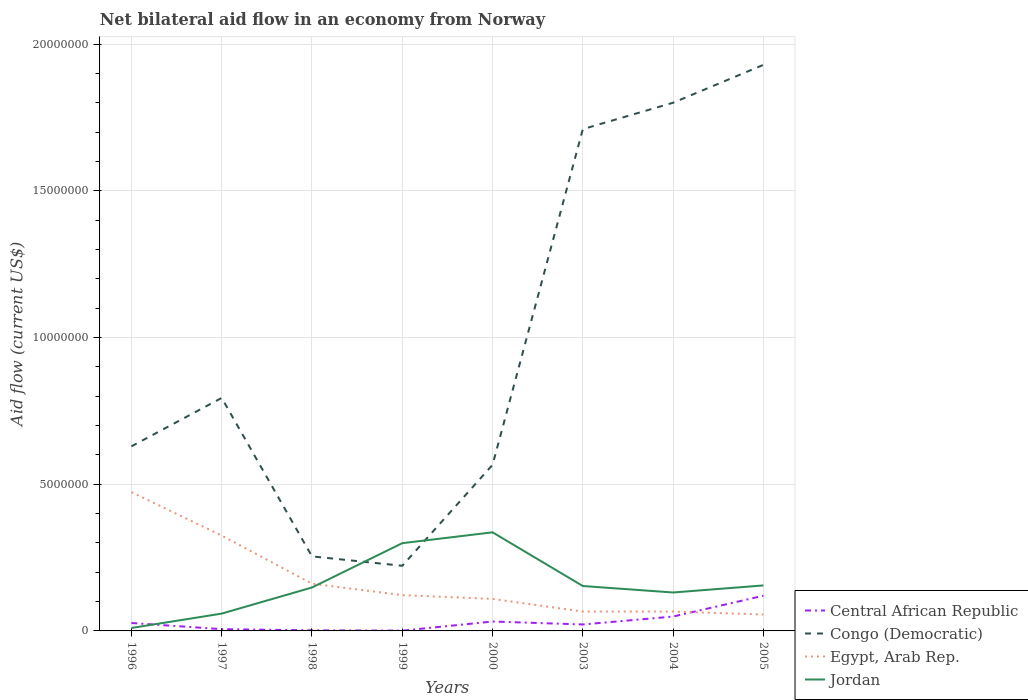What is the total net bilateral aid flow in Congo (Democratic) in the graph?
Keep it short and to the point. -1.68e+07. What is the difference between the highest and the second highest net bilateral aid flow in Egypt, Arab Rep.?
Your response must be concise. 4.17e+06. Is the net bilateral aid flow in Central African Republic strictly greater than the net bilateral aid flow in Jordan over the years?
Your response must be concise. No. How many years are there in the graph?
Offer a very short reply. 8. Does the graph contain any zero values?
Give a very brief answer. No. How many legend labels are there?
Ensure brevity in your answer.  4. What is the title of the graph?
Your response must be concise. Net bilateral aid flow in an economy from Norway. What is the Aid flow (current US$) of Central African Republic in 1996?
Keep it short and to the point. 2.70e+05. What is the Aid flow (current US$) of Congo (Democratic) in 1996?
Make the answer very short. 6.29e+06. What is the Aid flow (current US$) of Egypt, Arab Rep. in 1996?
Offer a very short reply. 4.73e+06. What is the Aid flow (current US$) of Central African Republic in 1997?
Keep it short and to the point. 6.00e+04. What is the Aid flow (current US$) in Congo (Democratic) in 1997?
Your answer should be very brief. 7.94e+06. What is the Aid flow (current US$) of Egypt, Arab Rep. in 1997?
Make the answer very short. 3.25e+06. What is the Aid flow (current US$) of Jordan in 1997?
Offer a terse response. 5.90e+05. What is the Aid flow (current US$) of Congo (Democratic) in 1998?
Make the answer very short. 2.54e+06. What is the Aid flow (current US$) of Egypt, Arab Rep. in 1998?
Ensure brevity in your answer.  1.61e+06. What is the Aid flow (current US$) in Jordan in 1998?
Offer a terse response. 1.48e+06. What is the Aid flow (current US$) of Congo (Democratic) in 1999?
Your answer should be very brief. 2.22e+06. What is the Aid flow (current US$) in Egypt, Arab Rep. in 1999?
Your answer should be very brief. 1.22e+06. What is the Aid flow (current US$) of Jordan in 1999?
Your response must be concise. 2.99e+06. What is the Aid flow (current US$) of Congo (Democratic) in 2000?
Give a very brief answer. 5.66e+06. What is the Aid flow (current US$) of Egypt, Arab Rep. in 2000?
Offer a terse response. 1.09e+06. What is the Aid flow (current US$) of Jordan in 2000?
Provide a short and direct response. 3.36e+06. What is the Aid flow (current US$) of Central African Republic in 2003?
Provide a short and direct response. 2.20e+05. What is the Aid flow (current US$) in Congo (Democratic) in 2003?
Your answer should be very brief. 1.71e+07. What is the Aid flow (current US$) of Jordan in 2003?
Your response must be concise. 1.53e+06. What is the Aid flow (current US$) of Central African Republic in 2004?
Your answer should be very brief. 4.90e+05. What is the Aid flow (current US$) in Congo (Democratic) in 2004?
Your answer should be very brief. 1.80e+07. What is the Aid flow (current US$) of Jordan in 2004?
Make the answer very short. 1.31e+06. What is the Aid flow (current US$) of Central African Republic in 2005?
Your answer should be very brief. 1.20e+06. What is the Aid flow (current US$) of Congo (Democratic) in 2005?
Offer a very short reply. 1.93e+07. What is the Aid flow (current US$) of Egypt, Arab Rep. in 2005?
Give a very brief answer. 5.60e+05. What is the Aid flow (current US$) of Jordan in 2005?
Offer a very short reply. 1.55e+06. Across all years, what is the maximum Aid flow (current US$) in Central African Republic?
Offer a very short reply. 1.20e+06. Across all years, what is the maximum Aid flow (current US$) in Congo (Democratic)?
Your answer should be very brief. 1.93e+07. Across all years, what is the maximum Aid flow (current US$) of Egypt, Arab Rep.?
Ensure brevity in your answer.  4.73e+06. Across all years, what is the maximum Aid flow (current US$) of Jordan?
Offer a very short reply. 3.36e+06. Across all years, what is the minimum Aid flow (current US$) in Central African Republic?
Provide a short and direct response. 10000. Across all years, what is the minimum Aid flow (current US$) of Congo (Democratic)?
Provide a short and direct response. 2.22e+06. Across all years, what is the minimum Aid flow (current US$) in Egypt, Arab Rep.?
Offer a terse response. 5.60e+05. What is the total Aid flow (current US$) of Central African Republic in the graph?
Your answer should be compact. 2.59e+06. What is the total Aid flow (current US$) of Congo (Democratic) in the graph?
Make the answer very short. 7.90e+07. What is the total Aid flow (current US$) of Egypt, Arab Rep. in the graph?
Give a very brief answer. 1.38e+07. What is the total Aid flow (current US$) in Jordan in the graph?
Provide a short and direct response. 1.29e+07. What is the difference between the Aid flow (current US$) of Congo (Democratic) in 1996 and that in 1997?
Offer a very short reply. -1.65e+06. What is the difference between the Aid flow (current US$) in Egypt, Arab Rep. in 1996 and that in 1997?
Offer a very short reply. 1.48e+06. What is the difference between the Aid flow (current US$) in Jordan in 1996 and that in 1997?
Keep it short and to the point. -4.90e+05. What is the difference between the Aid flow (current US$) of Congo (Democratic) in 1996 and that in 1998?
Your response must be concise. 3.75e+06. What is the difference between the Aid flow (current US$) of Egypt, Arab Rep. in 1996 and that in 1998?
Offer a very short reply. 3.12e+06. What is the difference between the Aid flow (current US$) of Jordan in 1996 and that in 1998?
Make the answer very short. -1.38e+06. What is the difference between the Aid flow (current US$) in Congo (Democratic) in 1996 and that in 1999?
Give a very brief answer. 4.07e+06. What is the difference between the Aid flow (current US$) in Egypt, Arab Rep. in 1996 and that in 1999?
Your answer should be very brief. 3.51e+06. What is the difference between the Aid flow (current US$) of Jordan in 1996 and that in 1999?
Your answer should be compact. -2.89e+06. What is the difference between the Aid flow (current US$) of Congo (Democratic) in 1996 and that in 2000?
Give a very brief answer. 6.30e+05. What is the difference between the Aid flow (current US$) of Egypt, Arab Rep. in 1996 and that in 2000?
Make the answer very short. 3.64e+06. What is the difference between the Aid flow (current US$) in Jordan in 1996 and that in 2000?
Provide a succinct answer. -3.26e+06. What is the difference between the Aid flow (current US$) in Congo (Democratic) in 1996 and that in 2003?
Give a very brief answer. -1.08e+07. What is the difference between the Aid flow (current US$) of Egypt, Arab Rep. in 1996 and that in 2003?
Provide a short and direct response. 4.07e+06. What is the difference between the Aid flow (current US$) in Jordan in 1996 and that in 2003?
Ensure brevity in your answer.  -1.43e+06. What is the difference between the Aid flow (current US$) in Congo (Democratic) in 1996 and that in 2004?
Offer a terse response. -1.17e+07. What is the difference between the Aid flow (current US$) of Egypt, Arab Rep. in 1996 and that in 2004?
Your answer should be very brief. 4.07e+06. What is the difference between the Aid flow (current US$) of Jordan in 1996 and that in 2004?
Provide a short and direct response. -1.21e+06. What is the difference between the Aid flow (current US$) of Central African Republic in 1996 and that in 2005?
Offer a terse response. -9.30e+05. What is the difference between the Aid flow (current US$) in Congo (Democratic) in 1996 and that in 2005?
Offer a terse response. -1.30e+07. What is the difference between the Aid flow (current US$) of Egypt, Arab Rep. in 1996 and that in 2005?
Give a very brief answer. 4.17e+06. What is the difference between the Aid flow (current US$) of Jordan in 1996 and that in 2005?
Provide a short and direct response. -1.45e+06. What is the difference between the Aid flow (current US$) of Central African Republic in 1997 and that in 1998?
Ensure brevity in your answer.  4.00e+04. What is the difference between the Aid flow (current US$) in Congo (Democratic) in 1997 and that in 1998?
Provide a succinct answer. 5.40e+06. What is the difference between the Aid flow (current US$) of Egypt, Arab Rep. in 1997 and that in 1998?
Your response must be concise. 1.64e+06. What is the difference between the Aid flow (current US$) in Jordan in 1997 and that in 1998?
Ensure brevity in your answer.  -8.90e+05. What is the difference between the Aid flow (current US$) of Congo (Democratic) in 1997 and that in 1999?
Make the answer very short. 5.72e+06. What is the difference between the Aid flow (current US$) in Egypt, Arab Rep. in 1997 and that in 1999?
Offer a terse response. 2.03e+06. What is the difference between the Aid flow (current US$) in Jordan in 1997 and that in 1999?
Your answer should be compact. -2.40e+06. What is the difference between the Aid flow (current US$) in Congo (Democratic) in 1997 and that in 2000?
Keep it short and to the point. 2.28e+06. What is the difference between the Aid flow (current US$) of Egypt, Arab Rep. in 1997 and that in 2000?
Offer a terse response. 2.16e+06. What is the difference between the Aid flow (current US$) of Jordan in 1997 and that in 2000?
Give a very brief answer. -2.77e+06. What is the difference between the Aid flow (current US$) in Congo (Democratic) in 1997 and that in 2003?
Your response must be concise. -9.16e+06. What is the difference between the Aid flow (current US$) of Egypt, Arab Rep. in 1997 and that in 2003?
Your answer should be very brief. 2.59e+06. What is the difference between the Aid flow (current US$) of Jordan in 1997 and that in 2003?
Ensure brevity in your answer.  -9.40e+05. What is the difference between the Aid flow (current US$) of Central African Republic in 1997 and that in 2004?
Your answer should be compact. -4.30e+05. What is the difference between the Aid flow (current US$) of Congo (Democratic) in 1997 and that in 2004?
Your answer should be very brief. -1.01e+07. What is the difference between the Aid flow (current US$) of Egypt, Arab Rep. in 1997 and that in 2004?
Provide a short and direct response. 2.59e+06. What is the difference between the Aid flow (current US$) of Jordan in 1997 and that in 2004?
Provide a short and direct response. -7.20e+05. What is the difference between the Aid flow (current US$) of Central African Republic in 1997 and that in 2005?
Give a very brief answer. -1.14e+06. What is the difference between the Aid flow (current US$) in Congo (Democratic) in 1997 and that in 2005?
Keep it short and to the point. -1.14e+07. What is the difference between the Aid flow (current US$) of Egypt, Arab Rep. in 1997 and that in 2005?
Offer a very short reply. 2.69e+06. What is the difference between the Aid flow (current US$) of Jordan in 1997 and that in 2005?
Provide a short and direct response. -9.60e+05. What is the difference between the Aid flow (current US$) in Congo (Democratic) in 1998 and that in 1999?
Your answer should be compact. 3.20e+05. What is the difference between the Aid flow (current US$) of Jordan in 1998 and that in 1999?
Ensure brevity in your answer.  -1.51e+06. What is the difference between the Aid flow (current US$) in Central African Republic in 1998 and that in 2000?
Your answer should be compact. -3.00e+05. What is the difference between the Aid flow (current US$) of Congo (Democratic) in 1998 and that in 2000?
Offer a very short reply. -3.12e+06. What is the difference between the Aid flow (current US$) of Egypt, Arab Rep. in 1998 and that in 2000?
Provide a short and direct response. 5.20e+05. What is the difference between the Aid flow (current US$) of Jordan in 1998 and that in 2000?
Give a very brief answer. -1.88e+06. What is the difference between the Aid flow (current US$) of Central African Republic in 1998 and that in 2003?
Ensure brevity in your answer.  -2.00e+05. What is the difference between the Aid flow (current US$) of Congo (Democratic) in 1998 and that in 2003?
Provide a succinct answer. -1.46e+07. What is the difference between the Aid flow (current US$) in Egypt, Arab Rep. in 1998 and that in 2003?
Your response must be concise. 9.50e+05. What is the difference between the Aid flow (current US$) of Central African Republic in 1998 and that in 2004?
Your answer should be very brief. -4.70e+05. What is the difference between the Aid flow (current US$) in Congo (Democratic) in 1998 and that in 2004?
Give a very brief answer. -1.55e+07. What is the difference between the Aid flow (current US$) in Egypt, Arab Rep. in 1998 and that in 2004?
Provide a short and direct response. 9.50e+05. What is the difference between the Aid flow (current US$) in Central African Republic in 1998 and that in 2005?
Give a very brief answer. -1.18e+06. What is the difference between the Aid flow (current US$) of Congo (Democratic) in 1998 and that in 2005?
Give a very brief answer. -1.68e+07. What is the difference between the Aid flow (current US$) of Egypt, Arab Rep. in 1998 and that in 2005?
Keep it short and to the point. 1.05e+06. What is the difference between the Aid flow (current US$) of Central African Republic in 1999 and that in 2000?
Ensure brevity in your answer.  -3.10e+05. What is the difference between the Aid flow (current US$) in Congo (Democratic) in 1999 and that in 2000?
Offer a very short reply. -3.44e+06. What is the difference between the Aid flow (current US$) in Jordan in 1999 and that in 2000?
Provide a succinct answer. -3.70e+05. What is the difference between the Aid flow (current US$) of Central African Republic in 1999 and that in 2003?
Your answer should be compact. -2.10e+05. What is the difference between the Aid flow (current US$) in Congo (Democratic) in 1999 and that in 2003?
Provide a short and direct response. -1.49e+07. What is the difference between the Aid flow (current US$) in Egypt, Arab Rep. in 1999 and that in 2003?
Your response must be concise. 5.60e+05. What is the difference between the Aid flow (current US$) of Jordan in 1999 and that in 2003?
Your response must be concise. 1.46e+06. What is the difference between the Aid flow (current US$) of Central African Republic in 1999 and that in 2004?
Your answer should be very brief. -4.80e+05. What is the difference between the Aid flow (current US$) in Congo (Democratic) in 1999 and that in 2004?
Make the answer very short. -1.58e+07. What is the difference between the Aid flow (current US$) of Egypt, Arab Rep. in 1999 and that in 2004?
Make the answer very short. 5.60e+05. What is the difference between the Aid flow (current US$) in Jordan in 1999 and that in 2004?
Provide a short and direct response. 1.68e+06. What is the difference between the Aid flow (current US$) in Central African Republic in 1999 and that in 2005?
Make the answer very short. -1.19e+06. What is the difference between the Aid flow (current US$) of Congo (Democratic) in 1999 and that in 2005?
Offer a very short reply. -1.71e+07. What is the difference between the Aid flow (current US$) in Jordan in 1999 and that in 2005?
Provide a short and direct response. 1.44e+06. What is the difference between the Aid flow (current US$) of Central African Republic in 2000 and that in 2003?
Provide a succinct answer. 1.00e+05. What is the difference between the Aid flow (current US$) of Congo (Democratic) in 2000 and that in 2003?
Offer a very short reply. -1.14e+07. What is the difference between the Aid flow (current US$) in Egypt, Arab Rep. in 2000 and that in 2003?
Your answer should be very brief. 4.30e+05. What is the difference between the Aid flow (current US$) in Jordan in 2000 and that in 2003?
Offer a very short reply. 1.83e+06. What is the difference between the Aid flow (current US$) in Congo (Democratic) in 2000 and that in 2004?
Provide a succinct answer. -1.23e+07. What is the difference between the Aid flow (current US$) of Jordan in 2000 and that in 2004?
Provide a succinct answer. 2.05e+06. What is the difference between the Aid flow (current US$) in Central African Republic in 2000 and that in 2005?
Your response must be concise. -8.80e+05. What is the difference between the Aid flow (current US$) of Congo (Democratic) in 2000 and that in 2005?
Keep it short and to the point. -1.36e+07. What is the difference between the Aid flow (current US$) of Egypt, Arab Rep. in 2000 and that in 2005?
Provide a succinct answer. 5.30e+05. What is the difference between the Aid flow (current US$) in Jordan in 2000 and that in 2005?
Offer a very short reply. 1.81e+06. What is the difference between the Aid flow (current US$) in Central African Republic in 2003 and that in 2004?
Give a very brief answer. -2.70e+05. What is the difference between the Aid flow (current US$) in Congo (Democratic) in 2003 and that in 2004?
Provide a succinct answer. -9.00e+05. What is the difference between the Aid flow (current US$) of Egypt, Arab Rep. in 2003 and that in 2004?
Offer a terse response. 0. What is the difference between the Aid flow (current US$) of Central African Republic in 2003 and that in 2005?
Your answer should be very brief. -9.80e+05. What is the difference between the Aid flow (current US$) in Congo (Democratic) in 2003 and that in 2005?
Your response must be concise. -2.19e+06. What is the difference between the Aid flow (current US$) of Central African Republic in 2004 and that in 2005?
Provide a succinct answer. -7.10e+05. What is the difference between the Aid flow (current US$) in Congo (Democratic) in 2004 and that in 2005?
Keep it short and to the point. -1.29e+06. What is the difference between the Aid flow (current US$) in Egypt, Arab Rep. in 2004 and that in 2005?
Your answer should be compact. 1.00e+05. What is the difference between the Aid flow (current US$) of Central African Republic in 1996 and the Aid flow (current US$) of Congo (Democratic) in 1997?
Keep it short and to the point. -7.67e+06. What is the difference between the Aid flow (current US$) in Central African Republic in 1996 and the Aid flow (current US$) in Egypt, Arab Rep. in 1997?
Keep it short and to the point. -2.98e+06. What is the difference between the Aid flow (current US$) in Central African Republic in 1996 and the Aid flow (current US$) in Jordan in 1997?
Offer a terse response. -3.20e+05. What is the difference between the Aid flow (current US$) of Congo (Democratic) in 1996 and the Aid flow (current US$) of Egypt, Arab Rep. in 1997?
Make the answer very short. 3.04e+06. What is the difference between the Aid flow (current US$) of Congo (Democratic) in 1996 and the Aid flow (current US$) of Jordan in 1997?
Offer a very short reply. 5.70e+06. What is the difference between the Aid flow (current US$) of Egypt, Arab Rep. in 1996 and the Aid flow (current US$) of Jordan in 1997?
Your answer should be very brief. 4.14e+06. What is the difference between the Aid flow (current US$) of Central African Republic in 1996 and the Aid flow (current US$) of Congo (Democratic) in 1998?
Provide a short and direct response. -2.27e+06. What is the difference between the Aid flow (current US$) in Central African Republic in 1996 and the Aid flow (current US$) in Egypt, Arab Rep. in 1998?
Provide a succinct answer. -1.34e+06. What is the difference between the Aid flow (current US$) of Central African Republic in 1996 and the Aid flow (current US$) of Jordan in 1998?
Ensure brevity in your answer.  -1.21e+06. What is the difference between the Aid flow (current US$) in Congo (Democratic) in 1996 and the Aid flow (current US$) in Egypt, Arab Rep. in 1998?
Ensure brevity in your answer.  4.68e+06. What is the difference between the Aid flow (current US$) in Congo (Democratic) in 1996 and the Aid flow (current US$) in Jordan in 1998?
Make the answer very short. 4.81e+06. What is the difference between the Aid flow (current US$) of Egypt, Arab Rep. in 1996 and the Aid flow (current US$) of Jordan in 1998?
Keep it short and to the point. 3.25e+06. What is the difference between the Aid flow (current US$) of Central African Republic in 1996 and the Aid flow (current US$) of Congo (Democratic) in 1999?
Provide a succinct answer. -1.95e+06. What is the difference between the Aid flow (current US$) in Central African Republic in 1996 and the Aid flow (current US$) in Egypt, Arab Rep. in 1999?
Your response must be concise. -9.50e+05. What is the difference between the Aid flow (current US$) in Central African Republic in 1996 and the Aid flow (current US$) in Jordan in 1999?
Your response must be concise. -2.72e+06. What is the difference between the Aid flow (current US$) of Congo (Democratic) in 1996 and the Aid flow (current US$) of Egypt, Arab Rep. in 1999?
Give a very brief answer. 5.07e+06. What is the difference between the Aid flow (current US$) of Congo (Democratic) in 1996 and the Aid flow (current US$) of Jordan in 1999?
Ensure brevity in your answer.  3.30e+06. What is the difference between the Aid flow (current US$) in Egypt, Arab Rep. in 1996 and the Aid flow (current US$) in Jordan in 1999?
Provide a succinct answer. 1.74e+06. What is the difference between the Aid flow (current US$) of Central African Republic in 1996 and the Aid flow (current US$) of Congo (Democratic) in 2000?
Give a very brief answer. -5.39e+06. What is the difference between the Aid flow (current US$) in Central African Republic in 1996 and the Aid flow (current US$) in Egypt, Arab Rep. in 2000?
Give a very brief answer. -8.20e+05. What is the difference between the Aid flow (current US$) in Central African Republic in 1996 and the Aid flow (current US$) in Jordan in 2000?
Ensure brevity in your answer.  -3.09e+06. What is the difference between the Aid flow (current US$) in Congo (Democratic) in 1996 and the Aid flow (current US$) in Egypt, Arab Rep. in 2000?
Give a very brief answer. 5.20e+06. What is the difference between the Aid flow (current US$) in Congo (Democratic) in 1996 and the Aid flow (current US$) in Jordan in 2000?
Keep it short and to the point. 2.93e+06. What is the difference between the Aid flow (current US$) in Egypt, Arab Rep. in 1996 and the Aid flow (current US$) in Jordan in 2000?
Give a very brief answer. 1.37e+06. What is the difference between the Aid flow (current US$) of Central African Republic in 1996 and the Aid flow (current US$) of Congo (Democratic) in 2003?
Your response must be concise. -1.68e+07. What is the difference between the Aid flow (current US$) of Central African Republic in 1996 and the Aid flow (current US$) of Egypt, Arab Rep. in 2003?
Give a very brief answer. -3.90e+05. What is the difference between the Aid flow (current US$) of Central African Republic in 1996 and the Aid flow (current US$) of Jordan in 2003?
Your response must be concise. -1.26e+06. What is the difference between the Aid flow (current US$) in Congo (Democratic) in 1996 and the Aid flow (current US$) in Egypt, Arab Rep. in 2003?
Provide a short and direct response. 5.63e+06. What is the difference between the Aid flow (current US$) in Congo (Democratic) in 1996 and the Aid flow (current US$) in Jordan in 2003?
Ensure brevity in your answer.  4.76e+06. What is the difference between the Aid flow (current US$) in Egypt, Arab Rep. in 1996 and the Aid flow (current US$) in Jordan in 2003?
Your response must be concise. 3.20e+06. What is the difference between the Aid flow (current US$) of Central African Republic in 1996 and the Aid flow (current US$) of Congo (Democratic) in 2004?
Give a very brief answer. -1.77e+07. What is the difference between the Aid flow (current US$) of Central African Republic in 1996 and the Aid flow (current US$) of Egypt, Arab Rep. in 2004?
Provide a short and direct response. -3.90e+05. What is the difference between the Aid flow (current US$) in Central African Republic in 1996 and the Aid flow (current US$) in Jordan in 2004?
Make the answer very short. -1.04e+06. What is the difference between the Aid flow (current US$) of Congo (Democratic) in 1996 and the Aid flow (current US$) of Egypt, Arab Rep. in 2004?
Your answer should be compact. 5.63e+06. What is the difference between the Aid flow (current US$) of Congo (Democratic) in 1996 and the Aid flow (current US$) of Jordan in 2004?
Make the answer very short. 4.98e+06. What is the difference between the Aid flow (current US$) in Egypt, Arab Rep. in 1996 and the Aid flow (current US$) in Jordan in 2004?
Give a very brief answer. 3.42e+06. What is the difference between the Aid flow (current US$) in Central African Republic in 1996 and the Aid flow (current US$) in Congo (Democratic) in 2005?
Give a very brief answer. -1.90e+07. What is the difference between the Aid flow (current US$) of Central African Republic in 1996 and the Aid flow (current US$) of Egypt, Arab Rep. in 2005?
Make the answer very short. -2.90e+05. What is the difference between the Aid flow (current US$) of Central African Republic in 1996 and the Aid flow (current US$) of Jordan in 2005?
Your answer should be very brief. -1.28e+06. What is the difference between the Aid flow (current US$) in Congo (Democratic) in 1996 and the Aid flow (current US$) in Egypt, Arab Rep. in 2005?
Offer a terse response. 5.73e+06. What is the difference between the Aid flow (current US$) in Congo (Democratic) in 1996 and the Aid flow (current US$) in Jordan in 2005?
Your response must be concise. 4.74e+06. What is the difference between the Aid flow (current US$) of Egypt, Arab Rep. in 1996 and the Aid flow (current US$) of Jordan in 2005?
Make the answer very short. 3.18e+06. What is the difference between the Aid flow (current US$) of Central African Republic in 1997 and the Aid flow (current US$) of Congo (Democratic) in 1998?
Make the answer very short. -2.48e+06. What is the difference between the Aid flow (current US$) of Central African Republic in 1997 and the Aid flow (current US$) of Egypt, Arab Rep. in 1998?
Make the answer very short. -1.55e+06. What is the difference between the Aid flow (current US$) of Central African Republic in 1997 and the Aid flow (current US$) of Jordan in 1998?
Your answer should be compact. -1.42e+06. What is the difference between the Aid flow (current US$) in Congo (Democratic) in 1997 and the Aid flow (current US$) in Egypt, Arab Rep. in 1998?
Keep it short and to the point. 6.33e+06. What is the difference between the Aid flow (current US$) in Congo (Democratic) in 1997 and the Aid flow (current US$) in Jordan in 1998?
Your response must be concise. 6.46e+06. What is the difference between the Aid flow (current US$) of Egypt, Arab Rep. in 1997 and the Aid flow (current US$) of Jordan in 1998?
Your answer should be compact. 1.77e+06. What is the difference between the Aid flow (current US$) of Central African Republic in 1997 and the Aid flow (current US$) of Congo (Democratic) in 1999?
Your answer should be very brief. -2.16e+06. What is the difference between the Aid flow (current US$) in Central African Republic in 1997 and the Aid flow (current US$) in Egypt, Arab Rep. in 1999?
Your answer should be very brief. -1.16e+06. What is the difference between the Aid flow (current US$) of Central African Republic in 1997 and the Aid flow (current US$) of Jordan in 1999?
Offer a very short reply. -2.93e+06. What is the difference between the Aid flow (current US$) in Congo (Democratic) in 1997 and the Aid flow (current US$) in Egypt, Arab Rep. in 1999?
Give a very brief answer. 6.72e+06. What is the difference between the Aid flow (current US$) in Congo (Democratic) in 1997 and the Aid flow (current US$) in Jordan in 1999?
Provide a succinct answer. 4.95e+06. What is the difference between the Aid flow (current US$) in Central African Republic in 1997 and the Aid flow (current US$) in Congo (Democratic) in 2000?
Your answer should be very brief. -5.60e+06. What is the difference between the Aid flow (current US$) of Central African Republic in 1997 and the Aid flow (current US$) of Egypt, Arab Rep. in 2000?
Provide a short and direct response. -1.03e+06. What is the difference between the Aid flow (current US$) of Central African Republic in 1997 and the Aid flow (current US$) of Jordan in 2000?
Offer a very short reply. -3.30e+06. What is the difference between the Aid flow (current US$) in Congo (Democratic) in 1997 and the Aid flow (current US$) in Egypt, Arab Rep. in 2000?
Provide a succinct answer. 6.85e+06. What is the difference between the Aid flow (current US$) of Congo (Democratic) in 1997 and the Aid flow (current US$) of Jordan in 2000?
Provide a short and direct response. 4.58e+06. What is the difference between the Aid flow (current US$) in Central African Republic in 1997 and the Aid flow (current US$) in Congo (Democratic) in 2003?
Make the answer very short. -1.70e+07. What is the difference between the Aid flow (current US$) in Central African Republic in 1997 and the Aid flow (current US$) in Egypt, Arab Rep. in 2003?
Keep it short and to the point. -6.00e+05. What is the difference between the Aid flow (current US$) of Central African Republic in 1997 and the Aid flow (current US$) of Jordan in 2003?
Provide a succinct answer. -1.47e+06. What is the difference between the Aid flow (current US$) of Congo (Democratic) in 1997 and the Aid flow (current US$) of Egypt, Arab Rep. in 2003?
Make the answer very short. 7.28e+06. What is the difference between the Aid flow (current US$) of Congo (Democratic) in 1997 and the Aid flow (current US$) of Jordan in 2003?
Your answer should be very brief. 6.41e+06. What is the difference between the Aid flow (current US$) in Egypt, Arab Rep. in 1997 and the Aid flow (current US$) in Jordan in 2003?
Your answer should be very brief. 1.72e+06. What is the difference between the Aid flow (current US$) of Central African Republic in 1997 and the Aid flow (current US$) of Congo (Democratic) in 2004?
Provide a short and direct response. -1.79e+07. What is the difference between the Aid flow (current US$) in Central African Republic in 1997 and the Aid flow (current US$) in Egypt, Arab Rep. in 2004?
Your answer should be very brief. -6.00e+05. What is the difference between the Aid flow (current US$) in Central African Republic in 1997 and the Aid flow (current US$) in Jordan in 2004?
Make the answer very short. -1.25e+06. What is the difference between the Aid flow (current US$) of Congo (Democratic) in 1997 and the Aid flow (current US$) of Egypt, Arab Rep. in 2004?
Your response must be concise. 7.28e+06. What is the difference between the Aid flow (current US$) in Congo (Democratic) in 1997 and the Aid flow (current US$) in Jordan in 2004?
Your answer should be very brief. 6.63e+06. What is the difference between the Aid flow (current US$) of Egypt, Arab Rep. in 1997 and the Aid flow (current US$) of Jordan in 2004?
Make the answer very short. 1.94e+06. What is the difference between the Aid flow (current US$) in Central African Republic in 1997 and the Aid flow (current US$) in Congo (Democratic) in 2005?
Keep it short and to the point. -1.92e+07. What is the difference between the Aid flow (current US$) of Central African Republic in 1997 and the Aid flow (current US$) of Egypt, Arab Rep. in 2005?
Provide a short and direct response. -5.00e+05. What is the difference between the Aid flow (current US$) in Central African Republic in 1997 and the Aid flow (current US$) in Jordan in 2005?
Keep it short and to the point. -1.49e+06. What is the difference between the Aid flow (current US$) of Congo (Democratic) in 1997 and the Aid flow (current US$) of Egypt, Arab Rep. in 2005?
Offer a very short reply. 7.38e+06. What is the difference between the Aid flow (current US$) in Congo (Democratic) in 1997 and the Aid flow (current US$) in Jordan in 2005?
Give a very brief answer. 6.39e+06. What is the difference between the Aid flow (current US$) of Egypt, Arab Rep. in 1997 and the Aid flow (current US$) of Jordan in 2005?
Make the answer very short. 1.70e+06. What is the difference between the Aid flow (current US$) in Central African Republic in 1998 and the Aid flow (current US$) in Congo (Democratic) in 1999?
Provide a short and direct response. -2.20e+06. What is the difference between the Aid flow (current US$) of Central African Republic in 1998 and the Aid flow (current US$) of Egypt, Arab Rep. in 1999?
Keep it short and to the point. -1.20e+06. What is the difference between the Aid flow (current US$) of Central African Republic in 1998 and the Aid flow (current US$) of Jordan in 1999?
Your answer should be very brief. -2.97e+06. What is the difference between the Aid flow (current US$) in Congo (Democratic) in 1998 and the Aid flow (current US$) in Egypt, Arab Rep. in 1999?
Ensure brevity in your answer.  1.32e+06. What is the difference between the Aid flow (current US$) in Congo (Democratic) in 1998 and the Aid flow (current US$) in Jordan in 1999?
Offer a terse response. -4.50e+05. What is the difference between the Aid flow (current US$) of Egypt, Arab Rep. in 1998 and the Aid flow (current US$) of Jordan in 1999?
Ensure brevity in your answer.  -1.38e+06. What is the difference between the Aid flow (current US$) in Central African Republic in 1998 and the Aid flow (current US$) in Congo (Democratic) in 2000?
Offer a terse response. -5.64e+06. What is the difference between the Aid flow (current US$) of Central African Republic in 1998 and the Aid flow (current US$) of Egypt, Arab Rep. in 2000?
Your answer should be very brief. -1.07e+06. What is the difference between the Aid flow (current US$) in Central African Republic in 1998 and the Aid flow (current US$) in Jordan in 2000?
Give a very brief answer. -3.34e+06. What is the difference between the Aid flow (current US$) in Congo (Democratic) in 1998 and the Aid flow (current US$) in Egypt, Arab Rep. in 2000?
Provide a short and direct response. 1.45e+06. What is the difference between the Aid flow (current US$) in Congo (Democratic) in 1998 and the Aid flow (current US$) in Jordan in 2000?
Your answer should be very brief. -8.20e+05. What is the difference between the Aid flow (current US$) of Egypt, Arab Rep. in 1998 and the Aid flow (current US$) of Jordan in 2000?
Offer a terse response. -1.75e+06. What is the difference between the Aid flow (current US$) in Central African Republic in 1998 and the Aid flow (current US$) in Congo (Democratic) in 2003?
Keep it short and to the point. -1.71e+07. What is the difference between the Aid flow (current US$) of Central African Republic in 1998 and the Aid flow (current US$) of Egypt, Arab Rep. in 2003?
Your answer should be very brief. -6.40e+05. What is the difference between the Aid flow (current US$) in Central African Republic in 1998 and the Aid flow (current US$) in Jordan in 2003?
Provide a short and direct response. -1.51e+06. What is the difference between the Aid flow (current US$) in Congo (Democratic) in 1998 and the Aid flow (current US$) in Egypt, Arab Rep. in 2003?
Your response must be concise. 1.88e+06. What is the difference between the Aid flow (current US$) of Congo (Democratic) in 1998 and the Aid flow (current US$) of Jordan in 2003?
Keep it short and to the point. 1.01e+06. What is the difference between the Aid flow (current US$) of Egypt, Arab Rep. in 1998 and the Aid flow (current US$) of Jordan in 2003?
Offer a very short reply. 8.00e+04. What is the difference between the Aid flow (current US$) in Central African Republic in 1998 and the Aid flow (current US$) in Congo (Democratic) in 2004?
Your response must be concise. -1.80e+07. What is the difference between the Aid flow (current US$) in Central African Republic in 1998 and the Aid flow (current US$) in Egypt, Arab Rep. in 2004?
Your answer should be very brief. -6.40e+05. What is the difference between the Aid flow (current US$) in Central African Republic in 1998 and the Aid flow (current US$) in Jordan in 2004?
Provide a succinct answer. -1.29e+06. What is the difference between the Aid flow (current US$) of Congo (Democratic) in 1998 and the Aid flow (current US$) of Egypt, Arab Rep. in 2004?
Provide a succinct answer. 1.88e+06. What is the difference between the Aid flow (current US$) in Congo (Democratic) in 1998 and the Aid flow (current US$) in Jordan in 2004?
Provide a succinct answer. 1.23e+06. What is the difference between the Aid flow (current US$) of Central African Republic in 1998 and the Aid flow (current US$) of Congo (Democratic) in 2005?
Provide a succinct answer. -1.93e+07. What is the difference between the Aid flow (current US$) in Central African Republic in 1998 and the Aid flow (current US$) in Egypt, Arab Rep. in 2005?
Offer a terse response. -5.40e+05. What is the difference between the Aid flow (current US$) in Central African Republic in 1998 and the Aid flow (current US$) in Jordan in 2005?
Provide a succinct answer. -1.53e+06. What is the difference between the Aid flow (current US$) of Congo (Democratic) in 1998 and the Aid flow (current US$) of Egypt, Arab Rep. in 2005?
Your answer should be compact. 1.98e+06. What is the difference between the Aid flow (current US$) in Congo (Democratic) in 1998 and the Aid flow (current US$) in Jordan in 2005?
Offer a terse response. 9.90e+05. What is the difference between the Aid flow (current US$) of Central African Republic in 1999 and the Aid flow (current US$) of Congo (Democratic) in 2000?
Provide a short and direct response. -5.65e+06. What is the difference between the Aid flow (current US$) of Central African Republic in 1999 and the Aid flow (current US$) of Egypt, Arab Rep. in 2000?
Provide a succinct answer. -1.08e+06. What is the difference between the Aid flow (current US$) of Central African Republic in 1999 and the Aid flow (current US$) of Jordan in 2000?
Provide a succinct answer. -3.35e+06. What is the difference between the Aid flow (current US$) of Congo (Democratic) in 1999 and the Aid flow (current US$) of Egypt, Arab Rep. in 2000?
Provide a short and direct response. 1.13e+06. What is the difference between the Aid flow (current US$) in Congo (Democratic) in 1999 and the Aid flow (current US$) in Jordan in 2000?
Provide a short and direct response. -1.14e+06. What is the difference between the Aid flow (current US$) in Egypt, Arab Rep. in 1999 and the Aid flow (current US$) in Jordan in 2000?
Ensure brevity in your answer.  -2.14e+06. What is the difference between the Aid flow (current US$) of Central African Republic in 1999 and the Aid flow (current US$) of Congo (Democratic) in 2003?
Your response must be concise. -1.71e+07. What is the difference between the Aid flow (current US$) of Central African Republic in 1999 and the Aid flow (current US$) of Egypt, Arab Rep. in 2003?
Provide a short and direct response. -6.50e+05. What is the difference between the Aid flow (current US$) of Central African Republic in 1999 and the Aid flow (current US$) of Jordan in 2003?
Offer a terse response. -1.52e+06. What is the difference between the Aid flow (current US$) of Congo (Democratic) in 1999 and the Aid flow (current US$) of Egypt, Arab Rep. in 2003?
Make the answer very short. 1.56e+06. What is the difference between the Aid flow (current US$) in Congo (Democratic) in 1999 and the Aid flow (current US$) in Jordan in 2003?
Ensure brevity in your answer.  6.90e+05. What is the difference between the Aid flow (current US$) in Egypt, Arab Rep. in 1999 and the Aid flow (current US$) in Jordan in 2003?
Provide a short and direct response. -3.10e+05. What is the difference between the Aid flow (current US$) of Central African Republic in 1999 and the Aid flow (current US$) of Congo (Democratic) in 2004?
Your answer should be compact. -1.80e+07. What is the difference between the Aid flow (current US$) in Central African Republic in 1999 and the Aid flow (current US$) in Egypt, Arab Rep. in 2004?
Your answer should be compact. -6.50e+05. What is the difference between the Aid flow (current US$) in Central African Republic in 1999 and the Aid flow (current US$) in Jordan in 2004?
Your answer should be very brief. -1.30e+06. What is the difference between the Aid flow (current US$) in Congo (Democratic) in 1999 and the Aid flow (current US$) in Egypt, Arab Rep. in 2004?
Keep it short and to the point. 1.56e+06. What is the difference between the Aid flow (current US$) of Congo (Democratic) in 1999 and the Aid flow (current US$) of Jordan in 2004?
Make the answer very short. 9.10e+05. What is the difference between the Aid flow (current US$) in Central African Republic in 1999 and the Aid flow (current US$) in Congo (Democratic) in 2005?
Ensure brevity in your answer.  -1.93e+07. What is the difference between the Aid flow (current US$) in Central African Republic in 1999 and the Aid flow (current US$) in Egypt, Arab Rep. in 2005?
Give a very brief answer. -5.50e+05. What is the difference between the Aid flow (current US$) of Central African Republic in 1999 and the Aid flow (current US$) of Jordan in 2005?
Your answer should be compact. -1.54e+06. What is the difference between the Aid flow (current US$) in Congo (Democratic) in 1999 and the Aid flow (current US$) in Egypt, Arab Rep. in 2005?
Your response must be concise. 1.66e+06. What is the difference between the Aid flow (current US$) of Congo (Democratic) in 1999 and the Aid flow (current US$) of Jordan in 2005?
Your answer should be very brief. 6.70e+05. What is the difference between the Aid flow (current US$) in Egypt, Arab Rep. in 1999 and the Aid flow (current US$) in Jordan in 2005?
Give a very brief answer. -3.30e+05. What is the difference between the Aid flow (current US$) of Central African Republic in 2000 and the Aid flow (current US$) of Congo (Democratic) in 2003?
Your answer should be very brief. -1.68e+07. What is the difference between the Aid flow (current US$) in Central African Republic in 2000 and the Aid flow (current US$) in Jordan in 2003?
Ensure brevity in your answer.  -1.21e+06. What is the difference between the Aid flow (current US$) of Congo (Democratic) in 2000 and the Aid flow (current US$) of Egypt, Arab Rep. in 2003?
Keep it short and to the point. 5.00e+06. What is the difference between the Aid flow (current US$) of Congo (Democratic) in 2000 and the Aid flow (current US$) of Jordan in 2003?
Keep it short and to the point. 4.13e+06. What is the difference between the Aid flow (current US$) in Egypt, Arab Rep. in 2000 and the Aid flow (current US$) in Jordan in 2003?
Give a very brief answer. -4.40e+05. What is the difference between the Aid flow (current US$) in Central African Republic in 2000 and the Aid flow (current US$) in Congo (Democratic) in 2004?
Offer a terse response. -1.77e+07. What is the difference between the Aid flow (current US$) in Central African Republic in 2000 and the Aid flow (current US$) in Egypt, Arab Rep. in 2004?
Offer a terse response. -3.40e+05. What is the difference between the Aid flow (current US$) in Central African Republic in 2000 and the Aid flow (current US$) in Jordan in 2004?
Make the answer very short. -9.90e+05. What is the difference between the Aid flow (current US$) of Congo (Democratic) in 2000 and the Aid flow (current US$) of Egypt, Arab Rep. in 2004?
Offer a terse response. 5.00e+06. What is the difference between the Aid flow (current US$) in Congo (Democratic) in 2000 and the Aid flow (current US$) in Jordan in 2004?
Your response must be concise. 4.35e+06. What is the difference between the Aid flow (current US$) of Egypt, Arab Rep. in 2000 and the Aid flow (current US$) of Jordan in 2004?
Ensure brevity in your answer.  -2.20e+05. What is the difference between the Aid flow (current US$) in Central African Republic in 2000 and the Aid flow (current US$) in Congo (Democratic) in 2005?
Offer a very short reply. -1.90e+07. What is the difference between the Aid flow (current US$) in Central African Republic in 2000 and the Aid flow (current US$) in Jordan in 2005?
Your response must be concise. -1.23e+06. What is the difference between the Aid flow (current US$) of Congo (Democratic) in 2000 and the Aid flow (current US$) of Egypt, Arab Rep. in 2005?
Your response must be concise. 5.10e+06. What is the difference between the Aid flow (current US$) in Congo (Democratic) in 2000 and the Aid flow (current US$) in Jordan in 2005?
Ensure brevity in your answer.  4.11e+06. What is the difference between the Aid flow (current US$) in Egypt, Arab Rep. in 2000 and the Aid flow (current US$) in Jordan in 2005?
Your response must be concise. -4.60e+05. What is the difference between the Aid flow (current US$) in Central African Republic in 2003 and the Aid flow (current US$) in Congo (Democratic) in 2004?
Give a very brief answer. -1.78e+07. What is the difference between the Aid flow (current US$) in Central African Republic in 2003 and the Aid flow (current US$) in Egypt, Arab Rep. in 2004?
Offer a terse response. -4.40e+05. What is the difference between the Aid flow (current US$) in Central African Republic in 2003 and the Aid flow (current US$) in Jordan in 2004?
Ensure brevity in your answer.  -1.09e+06. What is the difference between the Aid flow (current US$) of Congo (Democratic) in 2003 and the Aid flow (current US$) of Egypt, Arab Rep. in 2004?
Provide a succinct answer. 1.64e+07. What is the difference between the Aid flow (current US$) of Congo (Democratic) in 2003 and the Aid flow (current US$) of Jordan in 2004?
Ensure brevity in your answer.  1.58e+07. What is the difference between the Aid flow (current US$) of Egypt, Arab Rep. in 2003 and the Aid flow (current US$) of Jordan in 2004?
Your answer should be very brief. -6.50e+05. What is the difference between the Aid flow (current US$) of Central African Republic in 2003 and the Aid flow (current US$) of Congo (Democratic) in 2005?
Ensure brevity in your answer.  -1.91e+07. What is the difference between the Aid flow (current US$) of Central African Republic in 2003 and the Aid flow (current US$) of Egypt, Arab Rep. in 2005?
Provide a short and direct response. -3.40e+05. What is the difference between the Aid flow (current US$) of Central African Republic in 2003 and the Aid flow (current US$) of Jordan in 2005?
Offer a very short reply. -1.33e+06. What is the difference between the Aid flow (current US$) in Congo (Democratic) in 2003 and the Aid flow (current US$) in Egypt, Arab Rep. in 2005?
Make the answer very short. 1.65e+07. What is the difference between the Aid flow (current US$) in Congo (Democratic) in 2003 and the Aid flow (current US$) in Jordan in 2005?
Make the answer very short. 1.56e+07. What is the difference between the Aid flow (current US$) in Egypt, Arab Rep. in 2003 and the Aid flow (current US$) in Jordan in 2005?
Give a very brief answer. -8.90e+05. What is the difference between the Aid flow (current US$) of Central African Republic in 2004 and the Aid flow (current US$) of Congo (Democratic) in 2005?
Ensure brevity in your answer.  -1.88e+07. What is the difference between the Aid flow (current US$) in Central African Republic in 2004 and the Aid flow (current US$) in Egypt, Arab Rep. in 2005?
Keep it short and to the point. -7.00e+04. What is the difference between the Aid flow (current US$) of Central African Republic in 2004 and the Aid flow (current US$) of Jordan in 2005?
Your answer should be compact. -1.06e+06. What is the difference between the Aid flow (current US$) in Congo (Democratic) in 2004 and the Aid flow (current US$) in Egypt, Arab Rep. in 2005?
Keep it short and to the point. 1.74e+07. What is the difference between the Aid flow (current US$) of Congo (Democratic) in 2004 and the Aid flow (current US$) of Jordan in 2005?
Provide a short and direct response. 1.64e+07. What is the difference between the Aid flow (current US$) of Egypt, Arab Rep. in 2004 and the Aid flow (current US$) of Jordan in 2005?
Offer a very short reply. -8.90e+05. What is the average Aid flow (current US$) of Central African Republic per year?
Give a very brief answer. 3.24e+05. What is the average Aid flow (current US$) in Congo (Democratic) per year?
Your response must be concise. 9.88e+06. What is the average Aid flow (current US$) of Egypt, Arab Rep. per year?
Provide a succinct answer. 1.72e+06. What is the average Aid flow (current US$) of Jordan per year?
Your response must be concise. 1.61e+06. In the year 1996, what is the difference between the Aid flow (current US$) of Central African Republic and Aid flow (current US$) of Congo (Democratic)?
Your response must be concise. -6.02e+06. In the year 1996, what is the difference between the Aid flow (current US$) of Central African Republic and Aid flow (current US$) of Egypt, Arab Rep.?
Offer a very short reply. -4.46e+06. In the year 1996, what is the difference between the Aid flow (current US$) of Congo (Democratic) and Aid flow (current US$) of Egypt, Arab Rep.?
Offer a very short reply. 1.56e+06. In the year 1996, what is the difference between the Aid flow (current US$) in Congo (Democratic) and Aid flow (current US$) in Jordan?
Provide a succinct answer. 6.19e+06. In the year 1996, what is the difference between the Aid flow (current US$) of Egypt, Arab Rep. and Aid flow (current US$) of Jordan?
Ensure brevity in your answer.  4.63e+06. In the year 1997, what is the difference between the Aid flow (current US$) in Central African Republic and Aid flow (current US$) in Congo (Democratic)?
Your response must be concise. -7.88e+06. In the year 1997, what is the difference between the Aid flow (current US$) in Central African Republic and Aid flow (current US$) in Egypt, Arab Rep.?
Ensure brevity in your answer.  -3.19e+06. In the year 1997, what is the difference between the Aid flow (current US$) of Central African Republic and Aid flow (current US$) of Jordan?
Offer a very short reply. -5.30e+05. In the year 1997, what is the difference between the Aid flow (current US$) of Congo (Democratic) and Aid flow (current US$) of Egypt, Arab Rep.?
Offer a terse response. 4.69e+06. In the year 1997, what is the difference between the Aid flow (current US$) in Congo (Democratic) and Aid flow (current US$) in Jordan?
Provide a short and direct response. 7.35e+06. In the year 1997, what is the difference between the Aid flow (current US$) in Egypt, Arab Rep. and Aid flow (current US$) in Jordan?
Your response must be concise. 2.66e+06. In the year 1998, what is the difference between the Aid flow (current US$) in Central African Republic and Aid flow (current US$) in Congo (Democratic)?
Make the answer very short. -2.52e+06. In the year 1998, what is the difference between the Aid flow (current US$) of Central African Republic and Aid flow (current US$) of Egypt, Arab Rep.?
Keep it short and to the point. -1.59e+06. In the year 1998, what is the difference between the Aid flow (current US$) of Central African Republic and Aid flow (current US$) of Jordan?
Make the answer very short. -1.46e+06. In the year 1998, what is the difference between the Aid flow (current US$) in Congo (Democratic) and Aid flow (current US$) in Egypt, Arab Rep.?
Provide a succinct answer. 9.30e+05. In the year 1998, what is the difference between the Aid flow (current US$) in Congo (Democratic) and Aid flow (current US$) in Jordan?
Provide a succinct answer. 1.06e+06. In the year 1999, what is the difference between the Aid flow (current US$) in Central African Republic and Aid flow (current US$) in Congo (Democratic)?
Your answer should be very brief. -2.21e+06. In the year 1999, what is the difference between the Aid flow (current US$) of Central African Republic and Aid flow (current US$) of Egypt, Arab Rep.?
Keep it short and to the point. -1.21e+06. In the year 1999, what is the difference between the Aid flow (current US$) of Central African Republic and Aid flow (current US$) of Jordan?
Offer a terse response. -2.98e+06. In the year 1999, what is the difference between the Aid flow (current US$) of Congo (Democratic) and Aid flow (current US$) of Jordan?
Make the answer very short. -7.70e+05. In the year 1999, what is the difference between the Aid flow (current US$) of Egypt, Arab Rep. and Aid flow (current US$) of Jordan?
Offer a very short reply. -1.77e+06. In the year 2000, what is the difference between the Aid flow (current US$) of Central African Republic and Aid flow (current US$) of Congo (Democratic)?
Provide a succinct answer. -5.34e+06. In the year 2000, what is the difference between the Aid flow (current US$) in Central African Republic and Aid flow (current US$) in Egypt, Arab Rep.?
Your answer should be very brief. -7.70e+05. In the year 2000, what is the difference between the Aid flow (current US$) in Central African Republic and Aid flow (current US$) in Jordan?
Your answer should be compact. -3.04e+06. In the year 2000, what is the difference between the Aid flow (current US$) in Congo (Democratic) and Aid flow (current US$) in Egypt, Arab Rep.?
Your response must be concise. 4.57e+06. In the year 2000, what is the difference between the Aid flow (current US$) of Congo (Democratic) and Aid flow (current US$) of Jordan?
Keep it short and to the point. 2.30e+06. In the year 2000, what is the difference between the Aid flow (current US$) in Egypt, Arab Rep. and Aid flow (current US$) in Jordan?
Keep it short and to the point. -2.27e+06. In the year 2003, what is the difference between the Aid flow (current US$) of Central African Republic and Aid flow (current US$) of Congo (Democratic)?
Keep it short and to the point. -1.69e+07. In the year 2003, what is the difference between the Aid flow (current US$) in Central African Republic and Aid flow (current US$) in Egypt, Arab Rep.?
Your answer should be very brief. -4.40e+05. In the year 2003, what is the difference between the Aid flow (current US$) in Central African Republic and Aid flow (current US$) in Jordan?
Offer a very short reply. -1.31e+06. In the year 2003, what is the difference between the Aid flow (current US$) in Congo (Democratic) and Aid flow (current US$) in Egypt, Arab Rep.?
Give a very brief answer. 1.64e+07. In the year 2003, what is the difference between the Aid flow (current US$) of Congo (Democratic) and Aid flow (current US$) of Jordan?
Your response must be concise. 1.56e+07. In the year 2003, what is the difference between the Aid flow (current US$) in Egypt, Arab Rep. and Aid flow (current US$) in Jordan?
Keep it short and to the point. -8.70e+05. In the year 2004, what is the difference between the Aid flow (current US$) of Central African Republic and Aid flow (current US$) of Congo (Democratic)?
Your response must be concise. -1.75e+07. In the year 2004, what is the difference between the Aid flow (current US$) in Central African Republic and Aid flow (current US$) in Jordan?
Keep it short and to the point. -8.20e+05. In the year 2004, what is the difference between the Aid flow (current US$) in Congo (Democratic) and Aid flow (current US$) in Egypt, Arab Rep.?
Ensure brevity in your answer.  1.73e+07. In the year 2004, what is the difference between the Aid flow (current US$) of Congo (Democratic) and Aid flow (current US$) of Jordan?
Provide a short and direct response. 1.67e+07. In the year 2004, what is the difference between the Aid flow (current US$) in Egypt, Arab Rep. and Aid flow (current US$) in Jordan?
Offer a terse response. -6.50e+05. In the year 2005, what is the difference between the Aid flow (current US$) of Central African Republic and Aid flow (current US$) of Congo (Democratic)?
Offer a very short reply. -1.81e+07. In the year 2005, what is the difference between the Aid flow (current US$) of Central African Republic and Aid flow (current US$) of Egypt, Arab Rep.?
Give a very brief answer. 6.40e+05. In the year 2005, what is the difference between the Aid flow (current US$) of Central African Republic and Aid flow (current US$) of Jordan?
Offer a terse response. -3.50e+05. In the year 2005, what is the difference between the Aid flow (current US$) of Congo (Democratic) and Aid flow (current US$) of Egypt, Arab Rep.?
Provide a succinct answer. 1.87e+07. In the year 2005, what is the difference between the Aid flow (current US$) in Congo (Democratic) and Aid flow (current US$) in Jordan?
Your answer should be compact. 1.77e+07. In the year 2005, what is the difference between the Aid flow (current US$) of Egypt, Arab Rep. and Aid flow (current US$) of Jordan?
Give a very brief answer. -9.90e+05. What is the ratio of the Aid flow (current US$) in Congo (Democratic) in 1996 to that in 1997?
Your answer should be compact. 0.79. What is the ratio of the Aid flow (current US$) of Egypt, Arab Rep. in 1996 to that in 1997?
Offer a terse response. 1.46. What is the ratio of the Aid flow (current US$) in Jordan in 1996 to that in 1997?
Give a very brief answer. 0.17. What is the ratio of the Aid flow (current US$) in Central African Republic in 1996 to that in 1998?
Provide a succinct answer. 13.5. What is the ratio of the Aid flow (current US$) of Congo (Democratic) in 1996 to that in 1998?
Provide a succinct answer. 2.48. What is the ratio of the Aid flow (current US$) of Egypt, Arab Rep. in 1996 to that in 1998?
Keep it short and to the point. 2.94. What is the ratio of the Aid flow (current US$) in Jordan in 1996 to that in 1998?
Ensure brevity in your answer.  0.07. What is the ratio of the Aid flow (current US$) in Central African Republic in 1996 to that in 1999?
Ensure brevity in your answer.  27. What is the ratio of the Aid flow (current US$) of Congo (Democratic) in 1996 to that in 1999?
Your response must be concise. 2.83. What is the ratio of the Aid flow (current US$) of Egypt, Arab Rep. in 1996 to that in 1999?
Your response must be concise. 3.88. What is the ratio of the Aid flow (current US$) of Jordan in 1996 to that in 1999?
Your response must be concise. 0.03. What is the ratio of the Aid flow (current US$) of Central African Republic in 1996 to that in 2000?
Your answer should be compact. 0.84. What is the ratio of the Aid flow (current US$) in Congo (Democratic) in 1996 to that in 2000?
Offer a terse response. 1.11. What is the ratio of the Aid flow (current US$) in Egypt, Arab Rep. in 1996 to that in 2000?
Keep it short and to the point. 4.34. What is the ratio of the Aid flow (current US$) of Jordan in 1996 to that in 2000?
Provide a short and direct response. 0.03. What is the ratio of the Aid flow (current US$) of Central African Republic in 1996 to that in 2003?
Offer a terse response. 1.23. What is the ratio of the Aid flow (current US$) of Congo (Democratic) in 1996 to that in 2003?
Your response must be concise. 0.37. What is the ratio of the Aid flow (current US$) of Egypt, Arab Rep. in 1996 to that in 2003?
Make the answer very short. 7.17. What is the ratio of the Aid flow (current US$) in Jordan in 1996 to that in 2003?
Your response must be concise. 0.07. What is the ratio of the Aid flow (current US$) of Central African Republic in 1996 to that in 2004?
Make the answer very short. 0.55. What is the ratio of the Aid flow (current US$) of Congo (Democratic) in 1996 to that in 2004?
Your response must be concise. 0.35. What is the ratio of the Aid flow (current US$) of Egypt, Arab Rep. in 1996 to that in 2004?
Your response must be concise. 7.17. What is the ratio of the Aid flow (current US$) of Jordan in 1996 to that in 2004?
Offer a terse response. 0.08. What is the ratio of the Aid flow (current US$) in Central African Republic in 1996 to that in 2005?
Give a very brief answer. 0.23. What is the ratio of the Aid flow (current US$) in Congo (Democratic) in 1996 to that in 2005?
Provide a short and direct response. 0.33. What is the ratio of the Aid flow (current US$) of Egypt, Arab Rep. in 1996 to that in 2005?
Keep it short and to the point. 8.45. What is the ratio of the Aid flow (current US$) in Jordan in 1996 to that in 2005?
Offer a very short reply. 0.06. What is the ratio of the Aid flow (current US$) of Central African Republic in 1997 to that in 1998?
Your answer should be compact. 3. What is the ratio of the Aid flow (current US$) in Congo (Democratic) in 1997 to that in 1998?
Give a very brief answer. 3.13. What is the ratio of the Aid flow (current US$) in Egypt, Arab Rep. in 1997 to that in 1998?
Offer a very short reply. 2.02. What is the ratio of the Aid flow (current US$) of Jordan in 1997 to that in 1998?
Provide a short and direct response. 0.4. What is the ratio of the Aid flow (current US$) in Congo (Democratic) in 1997 to that in 1999?
Your response must be concise. 3.58. What is the ratio of the Aid flow (current US$) in Egypt, Arab Rep. in 1997 to that in 1999?
Offer a very short reply. 2.66. What is the ratio of the Aid flow (current US$) in Jordan in 1997 to that in 1999?
Your answer should be compact. 0.2. What is the ratio of the Aid flow (current US$) in Central African Republic in 1997 to that in 2000?
Your answer should be very brief. 0.19. What is the ratio of the Aid flow (current US$) in Congo (Democratic) in 1997 to that in 2000?
Your answer should be compact. 1.4. What is the ratio of the Aid flow (current US$) in Egypt, Arab Rep. in 1997 to that in 2000?
Make the answer very short. 2.98. What is the ratio of the Aid flow (current US$) in Jordan in 1997 to that in 2000?
Offer a very short reply. 0.18. What is the ratio of the Aid flow (current US$) in Central African Republic in 1997 to that in 2003?
Keep it short and to the point. 0.27. What is the ratio of the Aid flow (current US$) in Congo (Democratic) in 1997 to that in 2003?
Your response must be concise. 0.46. What is the ratio of the Aid flow (current US$) of Egypt, Arab Rep. in 1997 to that in 2003?
Offer a very short reply. 4.92. What is the ratio of the Aid flow (current US$) of Jordan in 1997 to that in 2003?
Offer a terse response. 0.39. What is the ratio of the Aid flow (current US$) in Central African Republic in 1997 to that in 2004?
Your response must be concise. 0.12. What is the ratio of the Aid flow (current US$) of Congo (Democratic) in 1997 to that in 2004?
Your answer should be very brief. 0.44. What is the ratio of the Aid flow (current US$) in Egypt, Arab Rep. in 1997 to that in 2004?
Your response must be concise. 4.92. What is the ratio of the Aid flow (current US$) in Jordan in 1997 to that in 2004?
Ensure brevity in your answer.  0.45. What is the ratio of the Aid flow (current US$) in Congo (Democratic) in 1997 to that in 2005?
Offer a very short reply. 0.41. What is the ratio of the Aid flow (current US$) in Egypt, Arab Rep. in 1997 to that in 2005?
Offer a very short reply. 5.8. What is the ratio of the Aid flow (current US$) of Jordan in 1997 to that in 2005?
Your response must be concise. 0.38. What is the ratio of the Aid flow (current US$) in Congo (Democratic) in 1998 to that in 1999?
Your answer should be very brief. 1.14. What is the ratio of the Aid flow (current US$) in Egypt, Arab Rep. in 1998 to that in 1999?
Provide a succinct answer. 1.32. What is the ratio of the Aid flow (current US$) of Jordan in 1998 to that in 1999?
Your response must be concise. 0.49. What is the ratio of the Aid flow (current US$) of Central African Republic in 1998 to that in 2000?
Provide a short and direct response. 0.06. What is the ratio of the Aid flow (current US$) in Congo (Democratic) in 1998 to that in 2000?
Make the answer very short. 0.45. What is the ratio of the Aid flow (current US$) of Egypt, Arab Rep. in 1998 to that in 2000?
Provide a succinct answer. 1.48. What is the ratio of the Aid flow (current US$) of Jordan in 1998 to that in 2000?
Keep it short and to the point. 0.44. What is the ratio of the Aid flow (current US$) in Central African Republic in 1998 to that in 2003?
Your answer should be very brief. 0.09. What is the ratio of the Aid flow (current US$) in Congo (Democratic) in 1998 to that in 2003?
Your response must be concise. 0.15. What is the ratio of the Aid flow (current US$) of Egypt, Arab Rep. in 1998 to that in 2003?
Ensure brevity in your answer.  2.44. What is the ratio of the Aid flow (current US$) of Jordan in 1998 to that in 2003?
Offer a terse response. 0.97. What is the ratio of the Aid flow (current US$) of Central African Republic in 1998 to that in 2004?
Keep it short and to the point. 0.04. What is the ratio of the Aid flow (current US$) in Congo (Democratic) in 1998 to that in 2004?
Your answer should be compact. 0.14. What is the ratio of the Aid flow (current US$) in Egypt, Arab Rep. in 1998 to that in 2004?
Provide a succinct answer. 2.44. What is the ratio of the Aid flow (current US$) in Jordan in 1998 to that in 2004?
Offer a very short reply. 1.13. What is the ratio of the Aid flow (current US$) of Central African Republic in 1998 to that in 2005?
Make the answer very short. 0.02. What is the ratio of the Aid flow (current US$) of Congo (Democratic) in 1998 to that in 2005?
Make the answer very short. 0.13. What is the ratio of the Aid flow (current US$) in Egypt, Arab Rep. in 1998 to that in 2005?
Offer a terse response. 2.88. What is the ratio of the Aid flow (current US$) in Jordan in 1998 to that in 2005?
Offer a very short reply. 0.95. What is the ratio of the Aid flow (current US$) in Central African Republic in 1999 to that in 2000?
Keep it short and to the point. 0.03. What is the ratio of the Aid flow (current US$) of Congo (Democratic) in 1999 to that in 2000?
Keep it short and to the point. 0.39. What is the ratio of the Aid flow (current US$) of Egypt, Arab Rep. in 1999 to that in 2000?
Your answer should be very brief. 1.12. What is the ratio of the Aid flow (current US$) in Jordan in 1999 to that in 2000?
Offer a very short reply. 0.89. What is the ratio of the Aid flow (current US$) in Central African Republic in 1999 to that in 2003?
Provide a succinct answer. 0.05. What is the ratio of the Aid flow (current US$) of Congo (Democratic) in 1999 to that in 2003?
Provide a succinct answer. 0.13. What is the ratio of the Aid flow (current US$) in Egypt, Arab Rep. in 1999 to that in 2003?
Offer a very short reply. 1.85. What is the ratio of the Aid flow (current US$) in Jordan in 1999 to that in 2003?
Ensure brevity in your answer.  1.95. What is the ratio of the Aid flow (current US$) in Central African Republic in 1999 to that in 2004?
Give a very brief answer. 0.02. What is the ratio of the Aid flow (current US$) in Congo (Democratic) in 1999 to that in 2004?
Your response must be concise. 0.12. What is the ratio of the Aid flow (current US$) in Egypt, Arab Rep. in 1999 to that in 2004?
Give a very brief answer. 1.85. What is the ratio of the Aid flow (current US$) of Jordan in 1999 to that in 2004?
Make the answer very short. 2.28. What is the ratio of the Aid flow (current US$) of Central African Republic in 1999 to that in 2005?
Offer a terse response. 0.01. What is the ratio of the Aid flow (current US$) in Congo (Democratic) in 1999 to that in 2005?
Ensure brevity in your answer.  0.12. What is the ratio of the Aid flow (current US$) in Egypt, Arab Rep. in 1999 to that in 2005?
Ensure brevity in your answer.  2.18. What is the ratio of the Aid flow (current US$) of Jordan in 1999 to that in 2005?
Offer a very short reply. 1.93. What is the ratio of the Aid flow (current US$) in Central African Republic in 2000 to that in 2003?
Provide a short and direct response. 1.45. What is the ratio of the Aid flow (current US$) in Congo (Democratic) in 2000 to that in 2003?
Provide a short and direct response. 0.33. What is the ratio of the Aid flow (current US$) of Egypt, Arab Rep. in 2000 to that in 2003?
Your response must be concise. 1.65. What is the ratio of the Aid flow (current US$) of Jordan in 2000 to that in 2003?
Ensure brevity in your answer.  2.2. What is the ratio of the Aid flow (current US$) of Central African Republic in 2000 to that in 2004?
Offer a terse response. 0.65. What is the ratio of the Aid flow (current US$) of Congo (Democratic) in 2000 to that in 2004?
Keep it short and to the point. 0.31. What is the ratio of the Aid flow (current US$) of Egypt, Arab Rep. in 2000 to that in 2004?
Your response must be concise. 1.65. What is the ratio of the Aid flow (current US$) in Jordan in 2000 to that in 2004?
Provide a succinct answer. 2.56. What is the ratio of the Aid flow (current US$) in Central African Republic in 2000 to that in 2005?
Your answer should be compact. 0.27. What is the ratio of the Aid flow (current US$) of Congo (Democratic) in 2000 to that in 2005?
Give a very brief answer. 0.29. What is the ratio of the Aid flow (current US$) in Egypt, Arab Rep. in 2000 to that in 2005?
Your answer should be compact. 1.95. What is the ratio of the Aid flow (current US$) of Jordan in 2000 to that in 2005?
Offer a terse response. 2.17. What is the ratio of the Aid flow (current US$) of Central African Republic in 2003 to that in 2004?
Make the answer very short. 0.45. What is the ratio of the Aid flow (current US$) of Egypt, Arab Rep. in 2003 to that in 2004?
Your response must be concise. 1. What is the ratio of the Aid flow (current US$) of Jordan in 2003 to that in 2004?
Provide a succinct answer. 1.17. What is the ratio of the Aid flow (current US$) in Central African Republic in 2003 to that in 2005?
Ensure brevity in your answer.  0.18. What is the ratio of the Aid flow (current US$) of Congo (Democratic) in 2003 to that in 2005?
Make the answer very short. 0.89. What is the ratio of the Aid flow (current US$) in Egypt, Arab Rep. in 2003 to that in 2005?
Ensure brevity in your answer.  1.18. What is the ratio of the Aid flow (current US$) of Jordan in 2003 to that in 2005?
Make the answer very short. 0.99. What is the ratio of the Aid flow (current US$) in Central African Republic in 2004 to that in 2005?
Your response must be concise. 0.41. What is the ratio of the Aid flow (current US$) in Congo (Democratic) in 2004 to that in 2005?
Provide a succinct answer. 0.93. What is the ratio of the Aid flow (current US$) of Egypt, Arab Rep. in 2004 to that in 2005?
Keep it short and to the point. 1.18. What is the ratio of the Aid flow (current US$) of Jordan in 2004 to that in 2005?
Give a very brief answer. 0.85. What is the difference between the highest and the second highest Aid flow (current US$) in Central African Republic?
Give a very brief answer. 7.10e+05. What is the difference between the highest and the second highest Aid flow (current US$) in Congo (Democratic)?
Provide a succinct answer. 1.29e+06. What is the difference between the highest and the second highest Aid flow (current US$) of Egypt, Arab Rep.?
Your answer should be compact. 1.48e+06. What is the difference between the highest and the second highest Aid flow (current US$) in Jordan?
Give a very brief answer. 3.70e+05. What is the difference between the highest and the lowest Aid flow (current US$) of Central African Republic?
Ensure brevity in your answer.  1.19e+06. What is the difference between the highest and the lowest Aid flow (current US$) in Congo (Democratic)?
Your answer should be compact. 1.71e+07. What is the difference between the highest and the lowest Aid flow (current US$) in Egypt, Arab Rep.?
Your answer should be compact. 4.17e+06. What is the difference between the highest and the lowest Aid flow (current US$) in Jordan?
Give a very brief answer. 3.26e+06. 